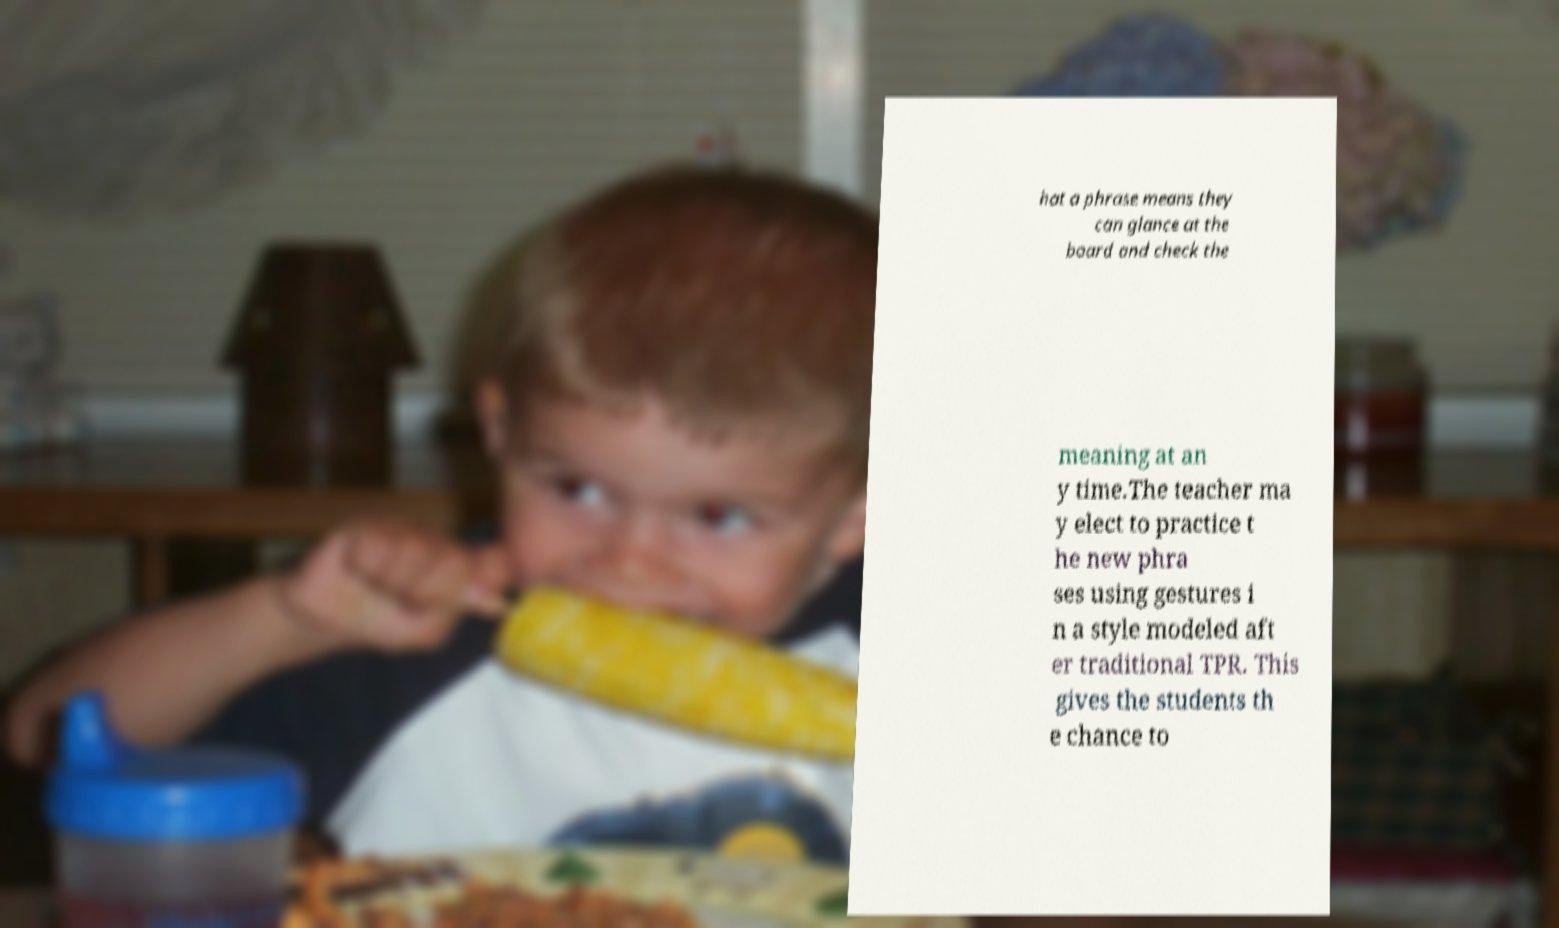Could you extract and type out the text from this image? hat a phrase means they can glance at the board and check the meaning at an y time.The teacher ma y elect to practice t he new phra ses using gestures i n a style modeled aft er traditional TPR. This gives the students th e chance to 